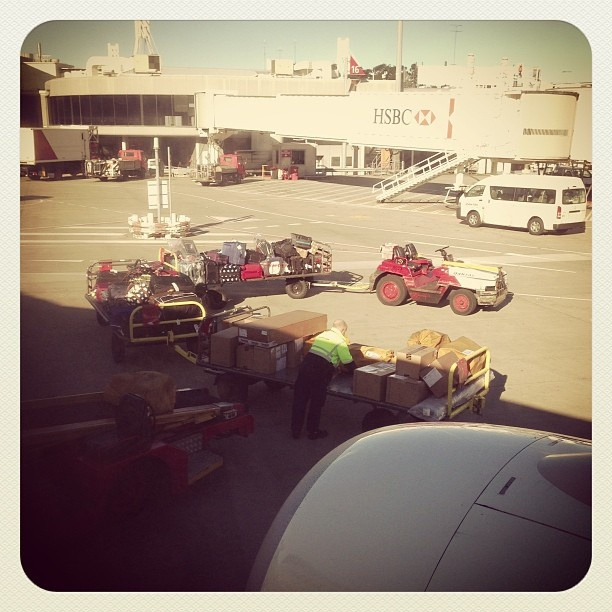Describe the objects in this image and their specific colors. I can see airplane in ivory, gray, and black tones, suitcase in ivory, black, brown, and maroon tones, truck in ivory, gray, brown, maroon, and tan tones, truck in ivory, brown, salmon, beige, and khaki tones, and bus in ivory, beige, gray, and tan tones in this image. 